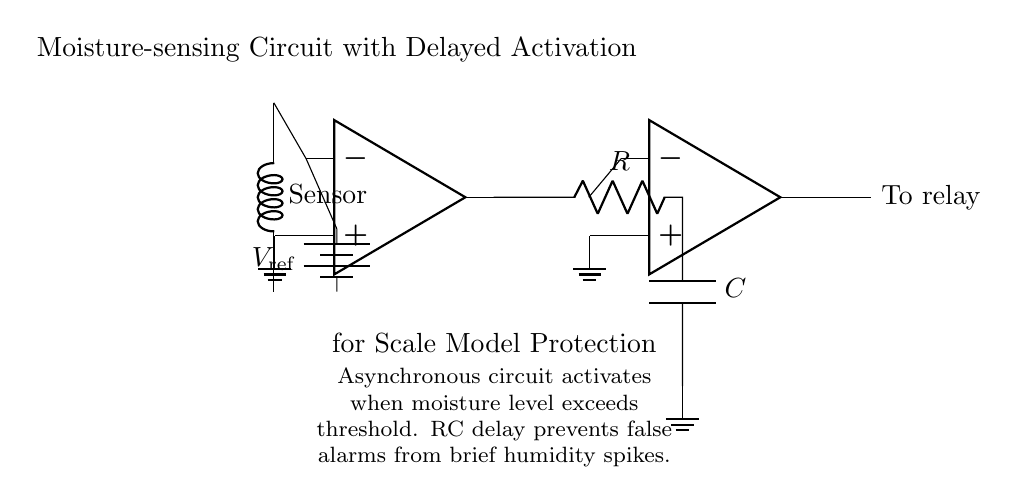What component detects moisture? The moisture sensor is the component that detects moisture. It is depicted at the left side of the circuit diagram.
Answer: Moisture Sensor What is the role of the comparator? The comparator compares the voltage from the moisture sensor to a reference voltage to determine if it exceeds a threshold. This is crucial for activating the next stage of the circuit.
Answer: Comparison What does the RC circuit do? The RC delay circuit is used to prevent false alarms by introducing a delay in the response of the circuit when the moisture level spikes momentarily. The resistor and capacitor work together to create this delay.
Answer: Prevent false alarms What type of circuit is used for moisture detection? The circuit is an asynchronous type because it activates based on the moisture condition without a constant clock signal driving it. This activation occurs when a specific moisture level is detected.
Answer: Asynchronous How is the output from the Schmitt trigger used? The output from the Schmitt trigger is directed to activate a relay, which can control a larger circuit or device based on the moisture detection. This indicates the critical function of the circuit as a moisture protection mechanism.
Answer: To relay 